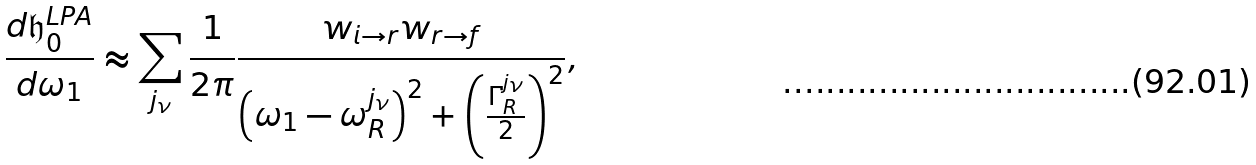<formula> <loc_0><loc_0><loc_500><loc_500>\frac { d \mathfrak { h } ^ { L P A } _ { 0 } } { d \omega _ { 1 } } \approx \sum _ { j _ { \nu } } \frac { 1 } { 2 \pi } \frac { w _ { i \rightarrow r } w _ { r \rightarrow f } } { \left ( \omega _ { 1 } - \omega _ { R } ^ { j _ { \nu } } \right ) ^ { 2 } + \left ( \frac { \Gamma _ { R } ^ { j _ { \nu } } } { 2 } \right ) ^ { 2 } } ,</formula> 